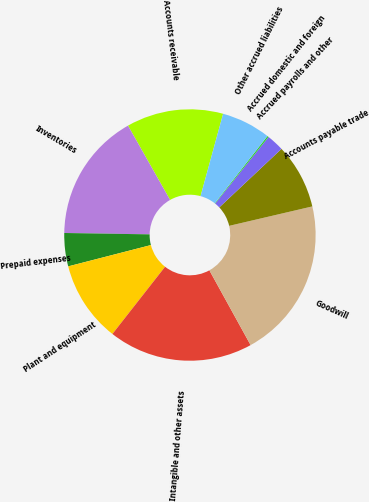Convert chart to OTSL. <chart><loc_0><loc_0><loc_500><loc_500><pie_chart><fcel>Accounts receivable<fcel>Inventories<fcel>Prepaid expenses<fcel>Plant and equipment<fcel>Intangible and other assets<fcel>Goodwill<fcel>Accounts payable trade<fcel>Accrued payrolls and other<fcel>Accrued domestic and foreign<fcel>Other accrued liabilities<nl><fcel>12.45%<fcel>16.54%<fcel>4.27%<fcel>10.41%<fcel>18.59%<fcel>20.63%<fcel>8.36%<fcel>2.23%<fcel>0.18%<fcel>6.32%<nl></chart> 